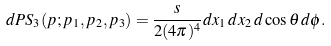Convert formula to latex. <formula><loc_0><loc_0><loc_500><loc_500>d P S _ { 3 } ( p ; p _ { 1 } , p _ { 2 } , p _ { 3 } ) = \frac { s } { 2 ( 4 \pi ) ^ { 4 } } d x _ { 1 } \, d x _ { 2 } \, d \cos \theta \, d \phi .</formula> 